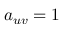<formula> <loc_0><loc_0><loc_500><loc_500>a _ { u v } = 1</formula> 